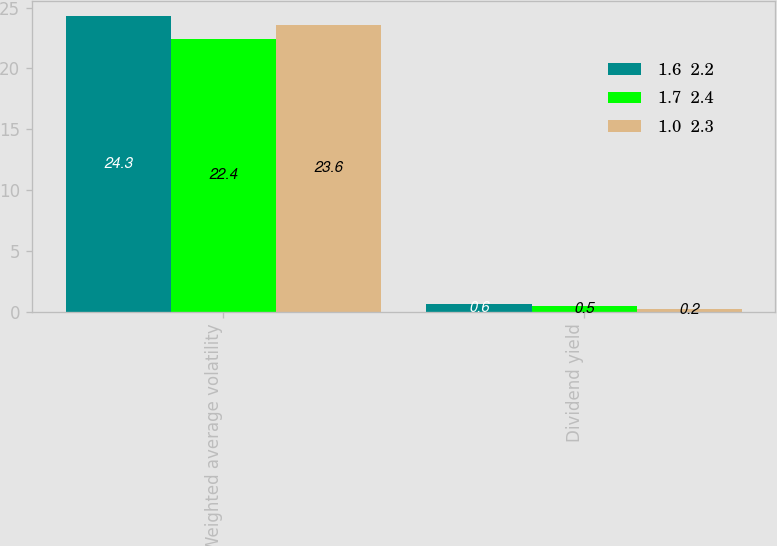Convert chart to OTSL. <chart><loc_0><loc_0><loc_500><loc_500><stacked_bar_chart><ecel><fcel>Weighted average volatility<fcel>Dividend yield<nl><fcel>1.6  2.2<fcel>24.3<fcel>0.6<nl><fcel>1.7  2.4<fcel>22.4<fcel>0.5<nl><fcel>1.0  2.3<fcel>23.6<fcel>0.2<nl></chart> 